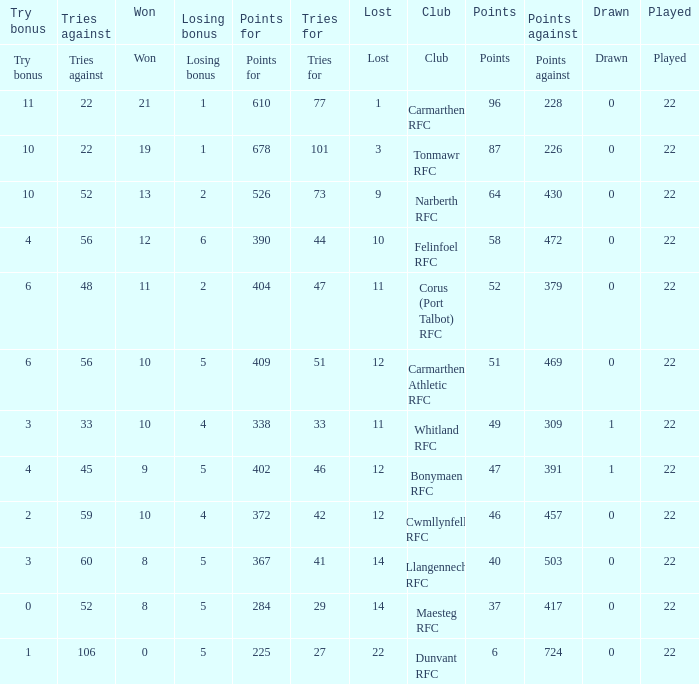Name the points against for 51 points 469.0. 